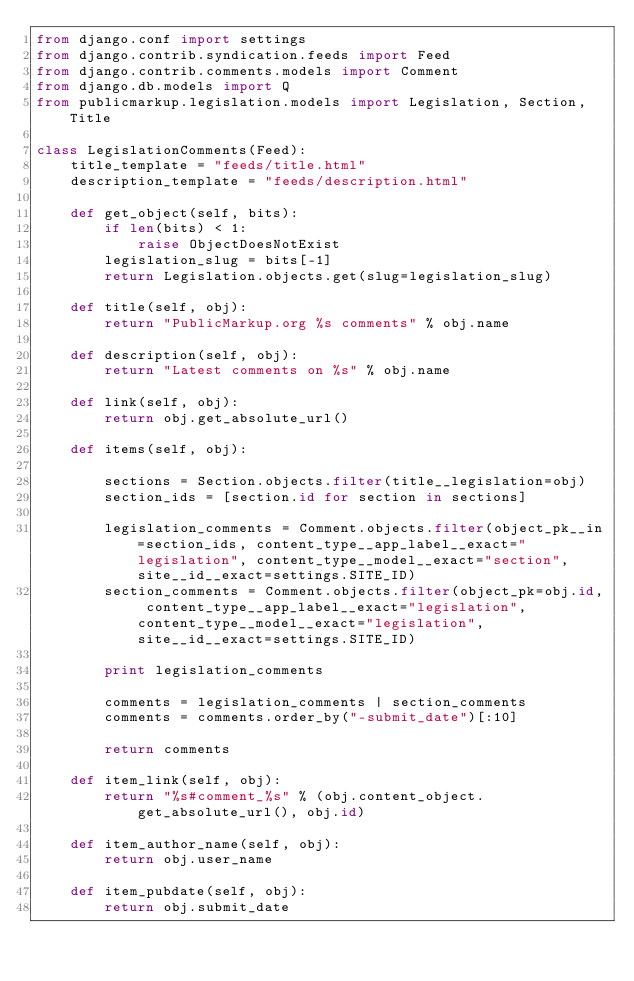<code> <loc_0><loc_0><loc_500><loc_500><_Python_>from django.conf import settings
from django.contrib.syndication.feeds import Feed
from django.contrib.comments.models import Comment
from django.db.models import Q
from publicmarkup.legislation.models import Legislation, Section, Title
        
class LegislationComments(Feed):
    title_template = "feeds/title.html"
    description_template = "feeds/description.html"
    
    def get_object(self, bits):
        if len(bits) < 1:
            raise ObjectDoesNotExist
        legislation_slug = bits[-1]
        return Legislation.objects.get(slug=legislation_slug)
        
    def title(self, obj):
        return "PublicMarkup.org %s comments" % obj.name
        
    def description(self, obj):
        return "Latest comments on %s" % obj.name
        
    def link(self, obj):
        return obj.get_absolute_url()
        
    def items(self, obj):
        
        sections = Section.objects.filter(title__legislation=obj)
        section_ids = [section.id for section in sections]
        
        legislation_comments = Comment.objects.filter(object_pk__in=section_ids, content_type__app_label__exact="legislation", content_type__model__exact="section", site__id__exact=settings.SITE_ID)
        section_comments = Comment.objects.filter(object_pk=obj.id, content_type__app_label__exact="legislation", content_type__model__exact="legislation", site__id__exact=settings.SITE_ID)
        
        print legislation_comments
        
        comments = legislation_comments | section_comments
        comments = comments.order_by("-submit_date")[:10]
        
        return comments
        
    def item_link(self, obj):
        return "%s#comment_%s" % (obj.content_object.get_absolute_url(), obj.id)
        
    def item_author_name(self, obj):
        return obj.user_name
        
    def item_pubdate(self, obj):
        return obj.submit_date</code> 